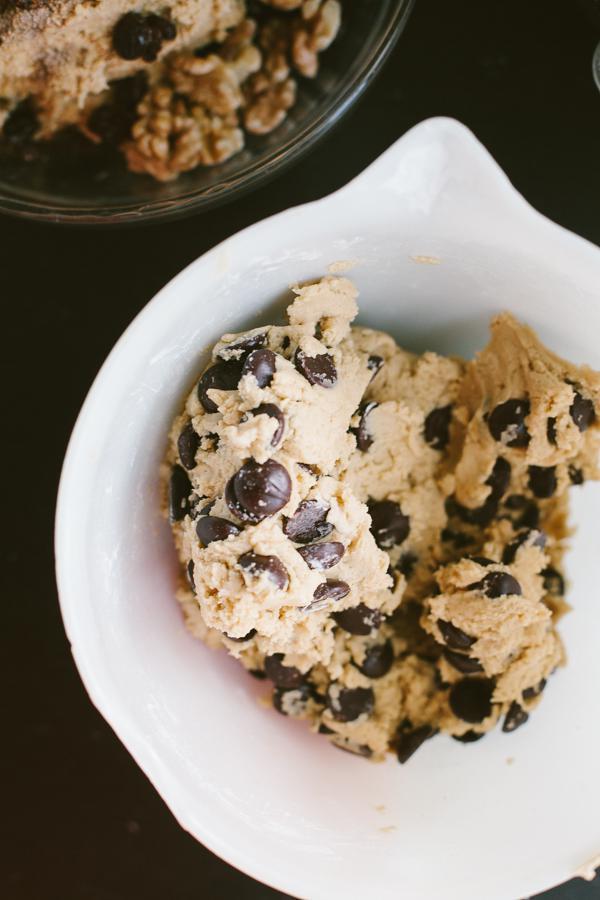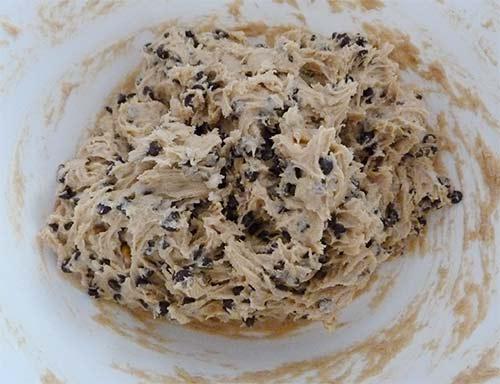The first image is the image on the left, the second image is the image on the right. Given the left and right images, does the statement "A wooden spoon touching a dough is visible." hold true? Answer yes or no. No. The first image is the image on the left, the second image is the image on the right. For the images displayed, is the sentence "Each image shows cookie dough in a bowl with the handle of a utensil sticking out of it." factually correct? Answer yes or no. No. 